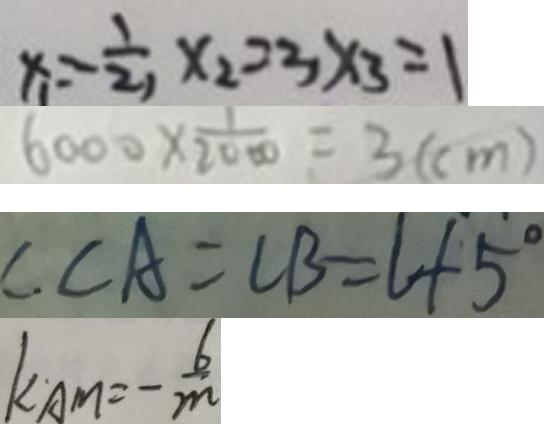<formula> <loc_0><loc_0><loc_500><loc_500>x _ { 1 } = - \frac { 1 } { 2 } , x _ { 2 } = 3 x _ { 3 } = 1 
 6 0 0 0 \times \frac { 1 } { 2 0 0 0 } = 3 ( c m ) 
 C \cdot C A = C B = l + 5 ^ { \circ } 
 k A M = - \frac { 6 } { m }</formula> 